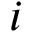Convert formula to latex. <formula><loc_0><loc_0><loc_500><loc_500>i</formula> 